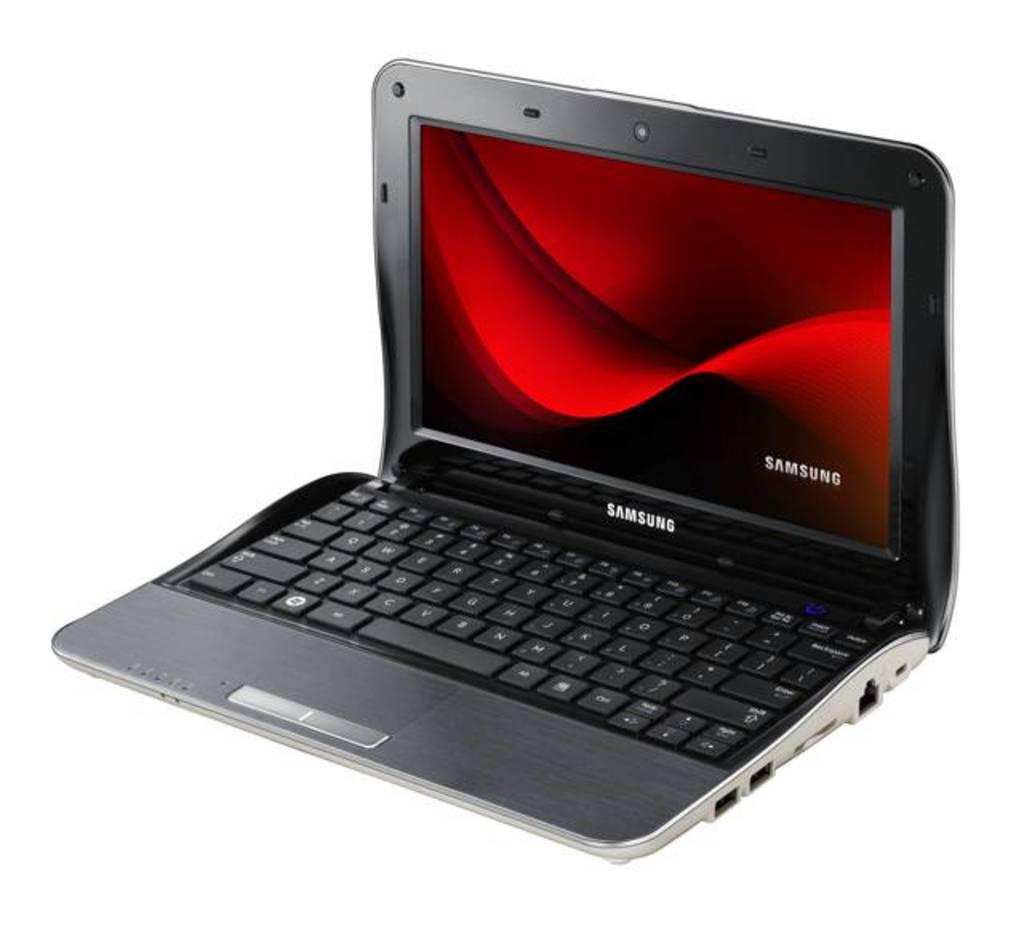<image>
Create a compact narrative representing the image presented. A SAMSUNG LAPTO WITH THE LID OPEN SHOWING RED SCREEN 